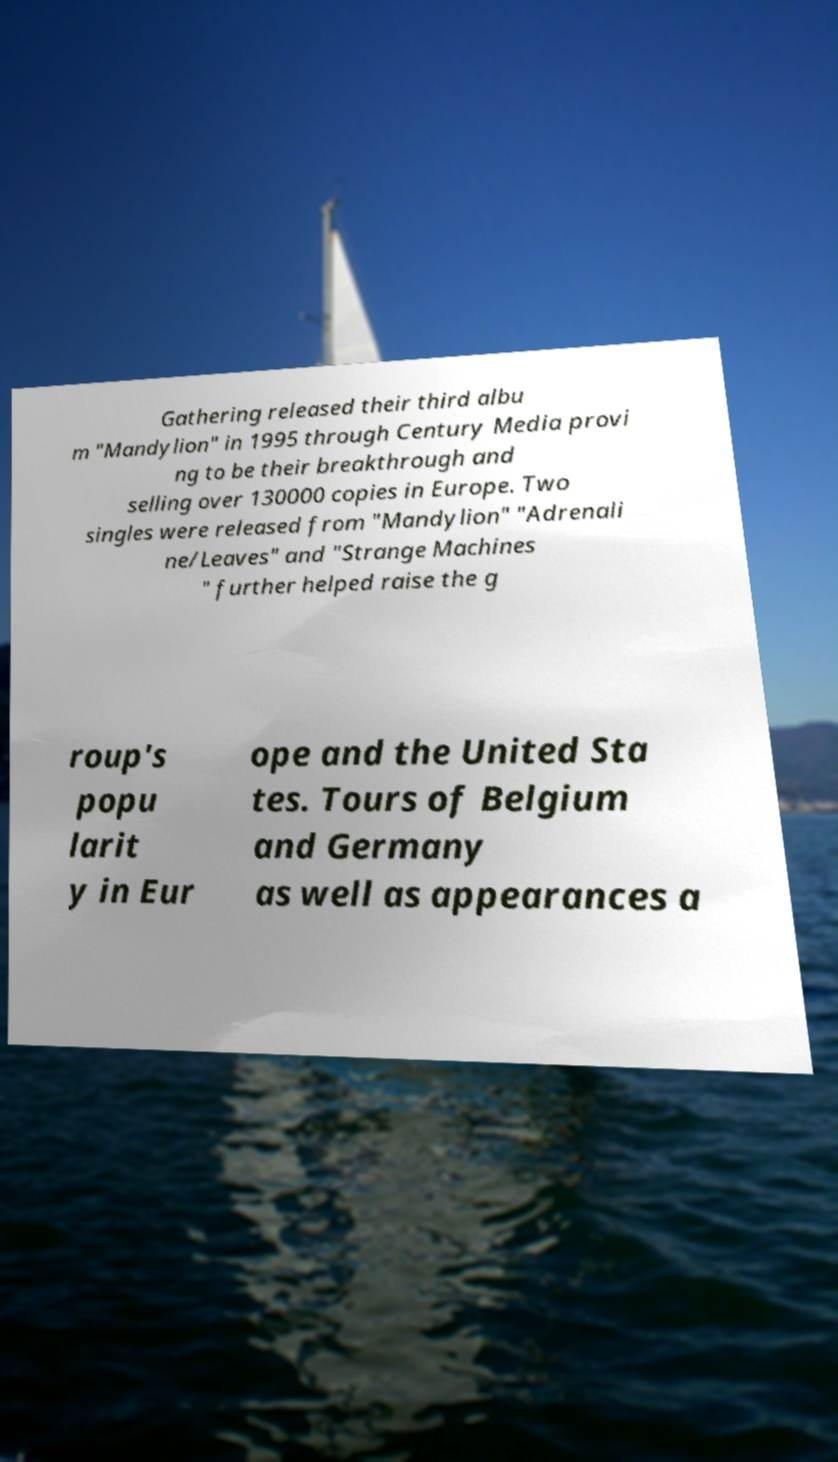There's text embedded in this image that I need extracted. Can you transcribe it verbatim? Gathering released their third albu m "Mandylion" in 1995 through Century Media provi ng to be their breakthrough and selling over 130000 copies in Europe. Two singles were released from "Mandylion" "Adrenali ne/Leaves" and "Strange Machines " further helped raise the g roup's popu larit y in Eur ope and the United Sta tes. Tours of Belgium and Germany as well as appearances a 